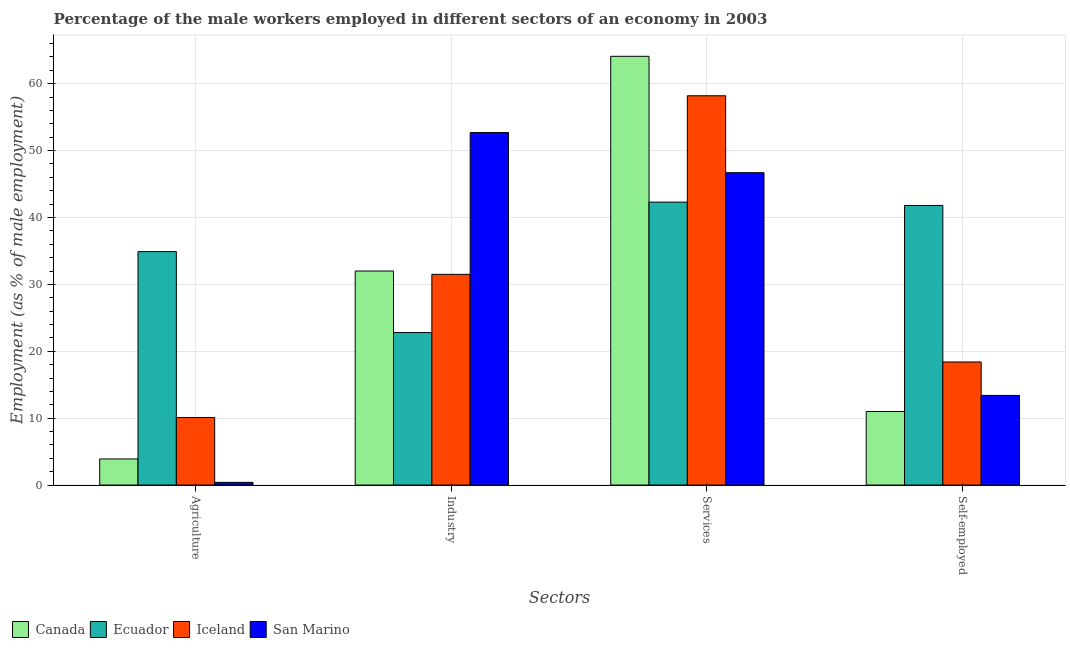How many bars are there on the 2nd tick from the left?
Offer a very short reply. 4. What is the label of the 4th group of bars from the left?
Offer a terse response. Self-employed. Across all countries, what is the maximum percentage of male workers in industry?
Your answer should be very brief. 52.7. Across all countries, what is the minimum percentage of male workers in services?
Your answer should be compact. 42.3. In which country was the percentage of male workers in industry minimum?
Ensure brevity in your answer.  Ecuador. What is the total percentage of male workers in agriculture in the graph?
Offer a terse response. 49.3. What is the difference between the percentage of male workers in services in Canada and that in Iceland?
Your response must be concise. 5.9. What is the difference between the percentage of self employed male workers in Canada and the percentage of male workers in services in Ecuador?
Provide a short and direct response. -31.3. What is the average percentage of self employed male workers per country?
Offer a terse response. 21.15. What is the difference between the percentage of male workers in agriculture and percentage of self employed male workers in Canada?
Provide a short and direct response. -7.1. In how many countries, is the percentage of male workers in services greater than 8 %?
Ensure brevity in your answer.  4. What is the ratio of the percentage of self employed male workers in Iceland to that in Ecuador?
Your answer should be compact. 0.44. Is the percentage of male workers in agriculture in Canada less than that in Iceland?
Provide a succinct answer. Yes. Is the difference between the percentage of male workers in industry in San Marino and Ecuador greater than the difference between the percentage of self employed male workers in San Marino and Ecuador?
Keep it short and to the point. Yes. What is the difference between the highest and the second highest percentage of self employed male workers?
Provide a succinct answer. 23.4. What is the difference between the highest and the lowest percentage of male workers in agriculture?
Make the answer very short. 34.5. Is the sum of the percentage of male workers in industry in Iceland and San Marino greater than the maximum percentage of male workers in services across all countries?
Make the answer very short. Yes. What does the 4th bar from the left in Industry represents?
Your response must be concise. San Marino. What does the 4th bar from the right in Self-employed represents?
Provide a succinct answer. Canada. How many countries are there in the graph?
Your answer should be very brief. 4. What is the difference between two consecutive major ticks on the Y-axis?
Your answer should be very brief. 10. Does the graph contain any zero values?
Offer a terse response. No. What is the title of the graph?
Provide a short and direct response. Percentage of the male workers employed in different sectors of an economy in 2003. What is the label or title of the X-axis?
Make the answer very short. Sectors. What is the label or title of the Y-axis?
Make the answer very short. Employment (as % of male employment). What is the Employment (as % of male employment) of Canada in Agriculture?
Make the answer very short. 3.9. What is the Employment (as % of male employment) in Ecuador in Agriculture?
Your response must be concise. 34.9. What is the Employment (as % of male employment) in Iceland in Agriculture?
Keep it short and to the point. 10.1. What is the Employment (as % of male employment) of San Marino in Agriculture?
Offer a terse response. 0.4. What is the Employment (as % of male employment) of Canada in Industry?
Give a very brief answer. 32. What is the Employment (as % of male employment) of Ecuador in Industry?
Provide a succinct answer. 22.8. What is the Employment (as % of male employment) in Iceland in Industry?
Your answer should be very brief. 31.5. What is the Employment (as % of male employment) of San Marino in Industry?
Provide a short and direct response. 52.7. What is the Employment (as % of male employment) in Canada in Services?
Make the answer very short. 64.1. What is the Employment (as % of male employment) of Ecuador in Services?
Provide a succinct answer. 42.3. What is the Employment (as % of male employment) of Iceland in Services?
Offer a terse response. 58.2. What is the Employment (as % of male employment) in San Marino in Services?
Ensure brevity in your answer.  46.7. What is the Employment (as % of male employment) in Canada in Self-employed?
Your answer should be very brief. 11. What is the Employment (as % of male employment) in Ecuador in Self-employed?
Your answer should be very brief. 41.8. What is the Employment (as % of male employment) in Iceland in Self-employed?
Make the answer very short. 18.4. What is the Employment (as % of male employment) of San Marino in Self-employed?
Your response must be concise. 13.4. Across all Sectors, what is the maximum Employment (as % of male employment) in Canada?
Provide a short and direct response. 64.1. Across all Sectors, what is the maximum Employment (as % of male employment) in Ecuador?
Make the answer very short. 42.3. Across all Sectors, what is the maximum Employment (as % of male employment) of Iceland?
Your answer should be very brief. 58.2. Across all Sectors, what is the maximum Employment (as % of male employment) in San Marino?
Your answer should be compact. 52.7. Across all Sectors, what is the minimum Employment (as % of male employment) of Canada?
Your response must be concise. 3.9. Across all Sectors, what is the minimum Employment (as % of male employment) of Ecuador?
Provide a short and direct response. 22.8. Across all Sectors, what is the minimum Employment (as % of male employment) of Iceland?
Your answer should be very brief. 10.1. Across all Sectors, what is the minimum Employment (as % of male employment) of San Marino?
Make the answer very short. 0.4. What is the total Employment (as % of male employment) in Canada in the graph?
Offer a very short reply. 111. What is the total Employment (as % of male employment) in Ecuador in the graph?
Give a very brief answer. 141.8. What is the total Employment (as % of male employment) in Iceland in the graph?
Offer a very short reply. 118.2. What is the total Employment (as % of male employment) of San Marino in the graph?
Your response must be concise. 113.2. What is the difference between the Employment (as % of male employment) of Canada in Agriculture and that in Industry?
Offer a terse response. -28.1. What is the difference between the Employment (as % of male employment) in Iceland in Agriculture and that in Industry?
Your answer should be very brief. -21.4. What is the difference between the Employment (as % of male employment) of San Marino in Agriculture and that in Industry?
Provide a succinct answer. -52.3. What is the difference between the Employment (as % of male employment) in Canada in Agriculture and that in Services?
Your response must be concise. -60.2. What is the difference between the Employment (as % of male employment) in Ecuador in Agriculture and that in Services?
Your response must be concise. -7.4. What is the difference between the Employment (as % of male employment) in Iceland in Agriculture and that in Services?
Ensure brevity in your answer.  -48.1. What is the difference between the Employment (as % of male employment) in San Marino in Agriculture and that in Services?
Ensure brevity in your answer.  -46.3. What is the difference between the Employment (as % of male employment) of Canada in Agriculture and that in Self-employed?
Offer a terse response. -7.1. What is the difference between the Employment (as % of male employment) in Ecuador in Agriculture and that in Self-employed?
Provide a short and direct response. -6.9. What is the difference between the Employment (as % of male employment) in Iceland in Agriculture and that in Self-employed?
Offer a terse response. -8.3. What is the difference between the Employment (as % of male employment) in Canada in Industry and that in Services?
Keep it short and to the point. -32.1. What is the difference between the Employment (as % of male employment) of Ecuador in Industry and that in Services?
Provide a short and direct response. -19.5. What is the difference between the Employment (as % of male employment) in Iceland in Industry and that in Services?
Ensure brevity in your answer.  -26.7. What is the difference between the Employment (as % of male employment) in San Marino in Industry and that in Services?
Give a very brief answer. 6. What is the difference between the Employment (as % of male employment) of Canada in Industry and that in Self-employed?
Offer a very short reply. 21. What is the difference between the Employment (as % of male employment) in San Marino in Industry and that in Self-employed?
Keep it short and to the point. 39.3. What is the difference between the Employment (as % of male employment) in Canada in Services and that in Self-employed?
Offer a very short reply. 53.1. What is the difference between the Employment (as % of male employment) of Iceland in Services and that in Self-employed?
Your answer should be very brief. 39.8. What is the difference between the Employment (as % of male employment) in San Marino in Services and that in Self-employed?
Offer a terse response. 33.3. What is the difference between the Employment (as % of male employment) in Canada in Agriculture and the Employment (as % of male employment) in Ecuador in Industry?
Your response must be concise. -18.9. What is the difference between the Employment (as % of male employment) of Canada in Agriculture and the Employment (as % of male employment) of Iceland in Industry?
Ensure brevity in your answer.  -27.6. What is the difference between the Employment (as % of male employment) in Canada in Agriculture and the Employment (as % of male employment) in San Marino in Industry?
Your answer should be very brief. -48.8. What is the difference between the Employment (as % of male employment) of Ecuador in Agriculture and the Employment (as % of male employment) of Iceland in Industry?
Provide a succinct answer. 3.4. What is the difference between the Employment (as % of male employment) in Ecuador in Agriculture and the Employment (as % of male employment) in San Marino in Industry?
Provide a short and direct response. -17.8. What is the difference between the Employment (as % of male employment) in Iceland in Agriculture and the Employment (as % of male employment) in San Marino in Industry?
Provide a short and direct response. -42.6. What is the difference between the Employment (as % of male employment) in Canada in Agriculture and the Employment (as % of male employment) in Ecuador in Services?
Make the answer very short. -38.4. What is the difference between the Employment (as % of male employment) in Canada in Agriculture and the Employment (as % of male employment) in Iceland in Services?
Your answer should be compact. -54.3. What is the difference between the Employment (as % of male employment) in Canada in Agriculture and the Employment (as % of male employment) in San Marino in Services?
Give a very brief answer. -42.8. What is the difference between the Employment (as % of male employment) in Ecuador in Agriculture and the Employment (as % of male employment) in Iceland in Services?
Keep it short and to the point. -23.3. What is the difference between the Employment (as % of male employment) of Iceland in Agriculture and the Employment (as % of male employment) of San Marino in Services?
Provide a short and direct response. -36.6. What is the difference between the Employment (as % of male employment) in Canada in Agriculture and the Employment (as % of male employment) in Ecuador in Self-employed?
Your answer should be very brief. -37.9. What is the difference between the Employment (as % of male employment) of Canada in Agriculture and the Employment (as % of male employment) of San Marino in Self-employed?
Provide a succinct answer. -9.5. What is the difference between the Employment (as % of male employment) in Canada in Industry and the Employment (as % of male employment) in Iceland in Services?
Make the answer very short. -26.2. What is the difference between the Employment (as % of male employment) in Canada in Industry and the Employment (as % of male employment) in San Marino in Services?
Offer a very short reply. -14.7. What is the difference between the Employment (as % of male employment) in Ecuador in Industry and the Employment (as % of male employment) in Iceland in Services?
Your answer should be compact. -35.4. What is the difference between the Employment (as % of male employment) in Ecuador in Industry and the Employment (as % of male employment) in San Marino in Services?
Make the answer very short. -23.9. What is the difference between the Employment (as % of male employment) in Iceland in Industry and the Employment (as % of male employment) in San Marino in Services?
Your answer should be very brief. -15.2. What is the difference between the Employment (as % of male employment) of Canada in Industry and the Employment (as % of male employment) of Ecuador in Self-employed?
Offer a terse response. -9.8. What is the difference between the Employment (as % of male employment) in Canada in Industry and the Employment (as % of male employment) in Iceland in Self-employed?
Your answer should be very brief. 13.6. What is the difference between the Employment (as % of male employment) in Ecuador in Industry and the Employment (as % of male employment) in San Marino in Self-employed?
Provide a succinct answer. 9.4. What is the difference between the Employment (as % of male employment) of Canada in Services and the Employment (as % of male employment) of Ecuador in Self-employed?
Offer a terse response. 22.3. What is the difference between the Employment (as % of male employment) in Canada in Services and the Employment (as % of male employment) in Iceland in Self-employed?
Your answer should be very brief. 45.7. What is the difference between the Employment (as % of male employment) in Canada in Services and the Employment (as % of male employment) in San Marino in Self-employed?
Provide a succinct answer. 50.7. What is the difference between the Employment (as % of male employment) in Ecuador in Services and the Employment (as % of male employment) in Iceland in Self-employed?
Offer a terse response. 23.9. What is the difference between the Employment (as % of male employment) of Ecuador in Services and the Employment (as % of male employment) of San Marino in Self-employed?
Provide a short and direct response. 28.9. What is the difference between the Employment (as % of male employment) in Iceland in Services and the Employment (as % of male employment) in San Marino in Self-employed?
Offer a very short reply. 44.8. What is the average Employment (as % of male employment) in Canada per Sectors?
Offer a very short reply. 27.75. What is the average Employment (as % of male employment) of Ecuador per Sectors?
Provide a short and direct response. 35.45. What is the average Employment (as % of male employment) in Iceland per Sectors?
Keep it short and to the point. 29.55. What is the average Employment (as % of male employment) of San Marino per Sectors?
Your answer should be compact. 28.3. What is the difference between the Employment (as % of male employment) of Canada and Employment (as % of male employment) of Ecuador in Agriculture?
Provide a succinct answer. -31. What is the difference between the Employment (as % of male employment) of Ecuador and Employment (as % of male employment) of Iceland in Agriculture?
Make the answer very short. 24.8. What is the difference between the Employment (as % of male employment) of Ecuador and Employment (as % of male employment) of San Marino in Agriculture?
Your answer should be very brief. 34.5. What is the difference between the Employment (as % of male employment) in Iceland and Employment (as % of male employment) in San Marino in Agriculture?
Provide a short and direct response. 9.7. What is the difference between the Employment (as % of male employment) of Canada and Employment (as % of male employment) of Ecuador in Industry?
Offer a very short reply. 9.2. What is the difference between the Employment (as % of male employment) of Canada and Employment (as % of male employment) of San Marino in Industry?
Offer a very short reply. -20.7. What is the difference between the Employment (as % of male employment) in Ecuador and Employment (as % of male employment) in Iceland in Industry?
Your answer should be compact. -8.7. What is the difference between the Employment (as % of male employment) in Ecuador and Employment (as % of male employment) in San Marino in Industry?
Ensure brevity in your answer.  -29.9. What is the difference between the Employment (as % of male employment) in Iceland and Employment (as % of male employment) in San Marino in Industry?
Keep it short and to the point. -21.2. What is the difference between the Employment (as % of male employment) in Canada and Employment (as % of male employment) in Ecuador in Services?
Provide a succinct answer. 21.8. What is the difference between the Employment (as % of male employment) in Ecuador and Employment (as % of male employment) in Iceland in Services?
Your answer should be compact. -15.9. What is the difference between the Employment (as % of male employment) in Ecuador and Employment (as % of male employment) in San Marino in Services?
Give a very brief answer. -4.4. What is the difference between the Employment (as % of male employment) of Iceland and Employment (as % of male employment) of San Marino in Services?
Ensure brevity in your answer.  11.5. What is the difference between the Employment (as % of male employment) of Canada and Employment (as % of male employment) of Ecuador in Self-employed?
Keep it short and to the point. -30.8. What is the difference between the Employment (as % of male employment) of Ecuador and Employment (as % of male employment) of Iceland in Self-employed?
Ensure brevity in your answer.  23.4. What is the difference between the Employment (as % of male employment) in Ecuador and Employment (as % of male employment) in San Marino in Self-employed?
Make the answer very short. 28.4. What is the ratio of the Employment (as % of male employment) of Canada in Agriculture to that in Industry?
Ensure brevity in your answer.  0.12. What is the ratio of the Employment (as % of male employment) in Ecuador in Agriculture to that in Industry?
Offer a very short reply. 1.53. What is the ratio of the Employment (as % of male employment) of Iceland in Agriculture to that in Industry?
Offer a very short reply. 0.32. What is the ratio of the Employment (as % of male employment) in San Marino in Agriculture to that in Industry?
Keep it short and to the point. 0.01. What is the ratio of the Employment (as % of male employment) in Canada in Agriculture to that in Services?
Your answer should be very brief. 0.06. What is the ratio of the Employment (as % of male employment) of Ecuador in Agriculture to that in Services?
Offer a terse response. 0.83. What is the ratio of the Employment (as % of male employment) of Iceland in Agriculture to that in Services?
Provide a succinct answer. 0.17. What is the ratio of the Employment (as % of male employment) in San Marino in Agriculture to that in Services?
Provide a succinct answer. 0.01. What is the ratio of the Employment (as % of male employment) in Canada in Agriculture to that in Self-employed?
Keep it short and to the point. 0.35. What is the ratio of the Employment (as % of male employment) in Ecuador in Agriculture to that in Self-employed?
Offer a terse response. 0.83. What is the ratio of the Employment (as % of male employment) in Iceland in Agriculture to that in Self-employed?
Provide a short and direct response. 0.55. What is the ratio of the Employment (as % of male employment) in San Marino in Agriculture to that in Self-employed?
Ensure brevity in your answer.  0.03. What is the ratio of the Employment (as % of male employment) of Canada in Industry to that in Services?
Your answer should be very brief. 0.5. What is the ratio of the Employment (as % of male employment) in Ecuador in Industry to that in Services?
Your response must be concise. 0.54. What is the ratio of the Employment (as % of male employment) of Iceland in Industry to that in Services?
Make the answer very short. 0.54. What is the ratio of the Employment (as % of male employment) of San Marino in Industry to that in Services?
Keep it short and to the point. 1.13. What is the ratio of the Employment (as % of male employment) in Canada in Industry to that in Self-employed?
Offer a very short reply. 2.91. What is the ratio of the Employment (as % of male employment) of Ecuador in Industry to that in Self-employed?
Make the answer very short. 0.55. What is the ratio of the Employment (as % of male employment) of Iceland in Industry to that in Self-employed?
Offer a very short reply. 1.71. What is the ratio of the Employment (as % of male employment) in San Marino in Industry to that in Self-employed?
Keep it short and to the point. 3.93. What is the ratio of the Employment (as % of male employment) of Canada in Services to that in Self-employed?
Offer a terse response. 5.83. What is the ratio of the Employment (as % of male employment) of Ecuador in Services to that in Self-employed?
Provide a succinct answer. 1.01. What is the ratio of the Employment (as % of male employment) in Iceland in Services to that in Self-employed?
Your response must be concise. 3.16. What is the ratio of the Employment (as % of male employment) in San Marino in Services to that in Self-employed?
Provide a succinct answer. 3.49. What is the difference between the highest and the second highest Employment (as % of male employment) in Canada?
Your response must be concise. 32.1. What is the difference between the highest and the second highest Employment (as % of male employment) of Ecuador?
Your answer should be compact. 0.5. What is the difference between the highest and the second highest Employment (as % of male employment) of Iceland?
Ensure brevity in your answer.  26.7. What is the difference between the highest and the lowest Employment (as % of male employment) of Canada?
Ensure brevity in your answer.  60.2. What is the difference between the highest and the lowest Employment (as % of male employment) in Ecuador?
Provide a short and direct response. 19.5. What is the difference between the highest and the lowest Employment (as % of male employment) of Iceland?
Your answer should be compact. 48.1. What is the difference between the highest and the lowest Employment (as % of male employment) of San Marino?
Your answer should be compact. 52.3. 